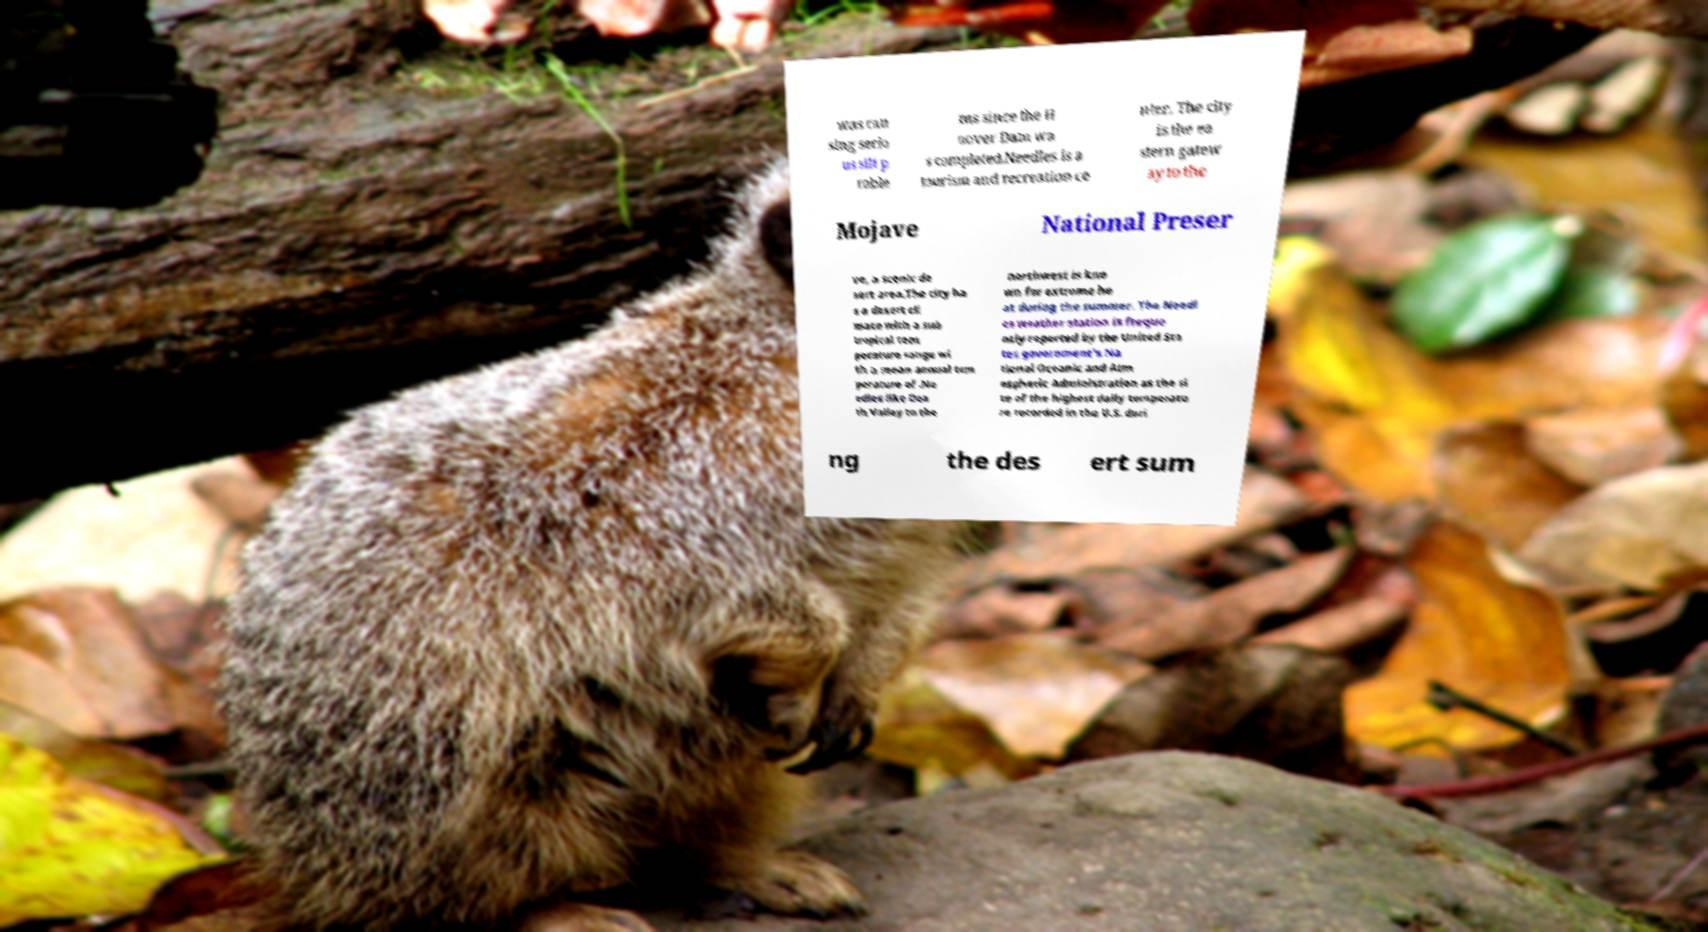Could you extract and type out the text from this image? was cau sing serio us silt p roble ms since the H oover Dam wa s completed.Needles is a tourism and recreation ce nter. The city is the ea stern gatew ay to the Mojave National Preser ve, a scenic de sert area.The city ha s a desert cli mate with a sub tropical tem perature range wi th a mean annual tem perature of .Ne edles like Dea th Valley to the northwest is kno wn for extreme he at during the summer. The Needl es weather station is freque ntly reported by the United Sta tes government's Na tional Oceanic and Atm ospheric Administration as the si te of the highest daily temperatu re recorded in the U.S. duri ng the des ert sum 